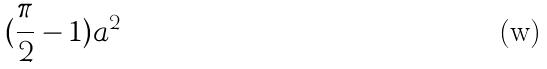Convert formula to latex. <formula><loc_0><loc_0><loc_500><loc_500>( \frac { \pi } { 2 } - 1 ) a ^ { 2 }</formula> 